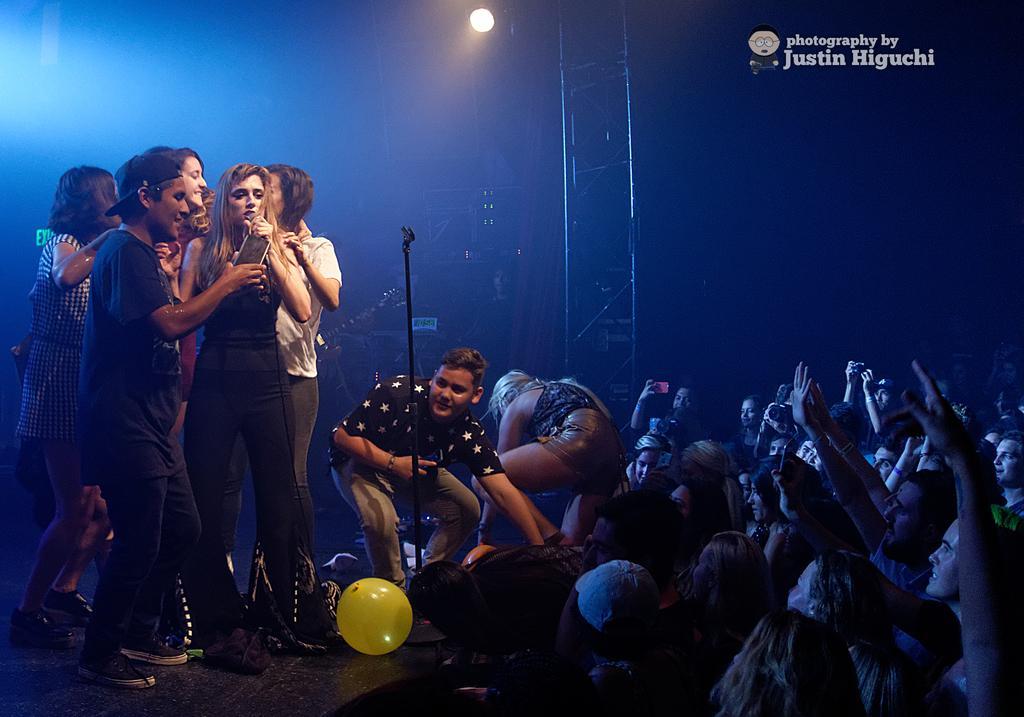Could you give a brief overview of what you see in this image? In this picture we can see some people are standing, a person on the left side is holding a mobile phone, we can see a balloon at the bottom, there is a stand in the middle, there is some text at the right top of the picture, we can see a light in the background. 